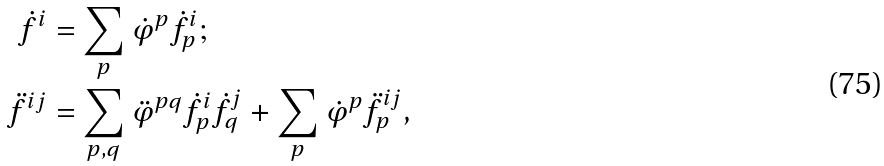<formula> <loc_0><loc_0><loc_500><loc_500>\dot { f } ^ { i } & = \sum _ { p } \dot { \varphi } ^ { p } \dot { f } _ { p } ^ { i } ; \\ \ddot { f } ^ { i j } & = \sum _ { p , q } \ddot { \varphi } ^ { p q } \dot { f } _ { p } ^ { i } \dot { f } _ { q } ^ { j } + \sum _ { p } \dot { \varphi } ^ { p } \ddot { f } _ { p } ^ { i j } ,</formula> 